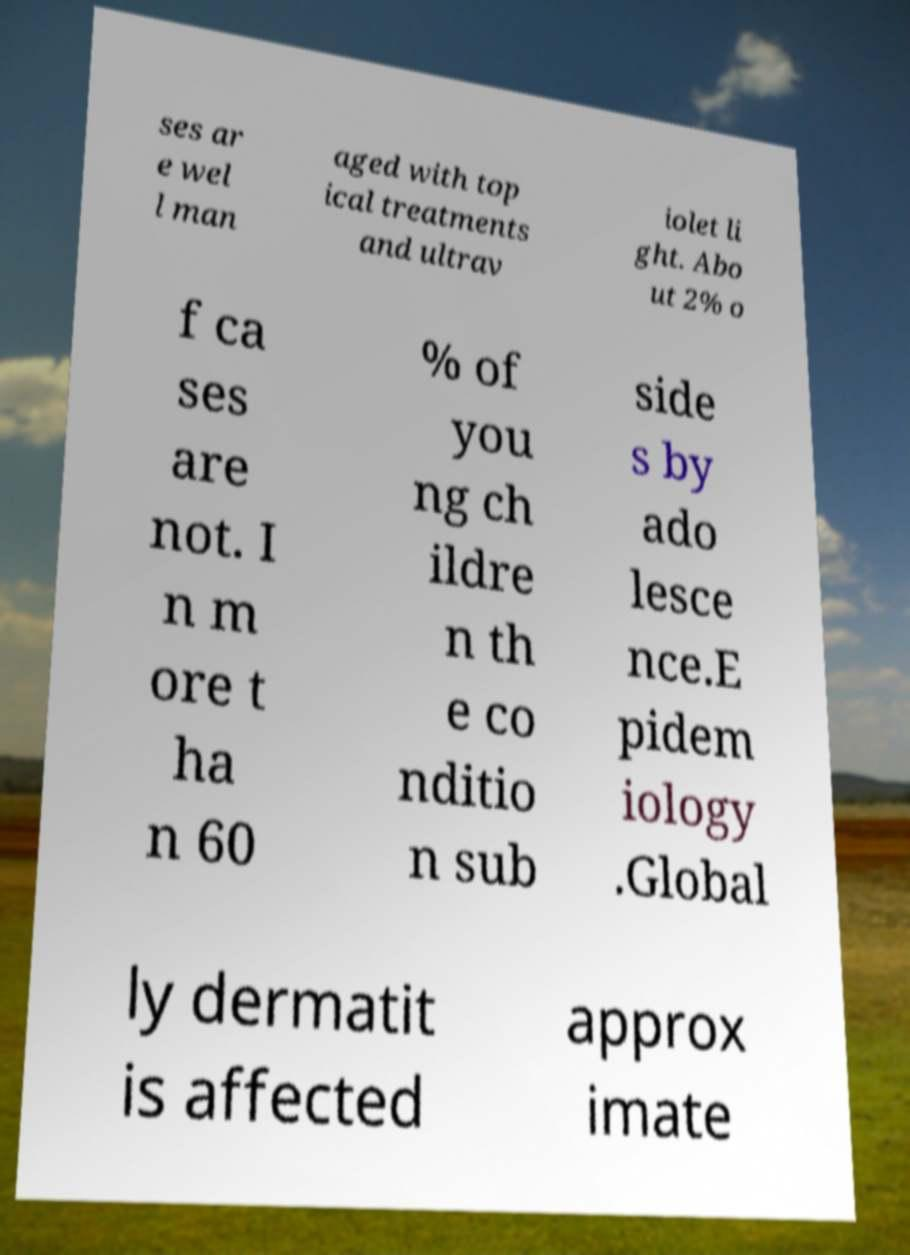There's text embedded in this image that I need extracted. Can you transcribe it verbatim? ses ar e wel l man aged with top ical treatments and ultrav iolet li ght. Abo ut 2% o f ca ses are not. I n m ore t ha n 60 % of you ng ch ildre n th e co nditio n sub side s by ado lesce nce.E pidem iology .Global ly dermatit is affected approx imate 